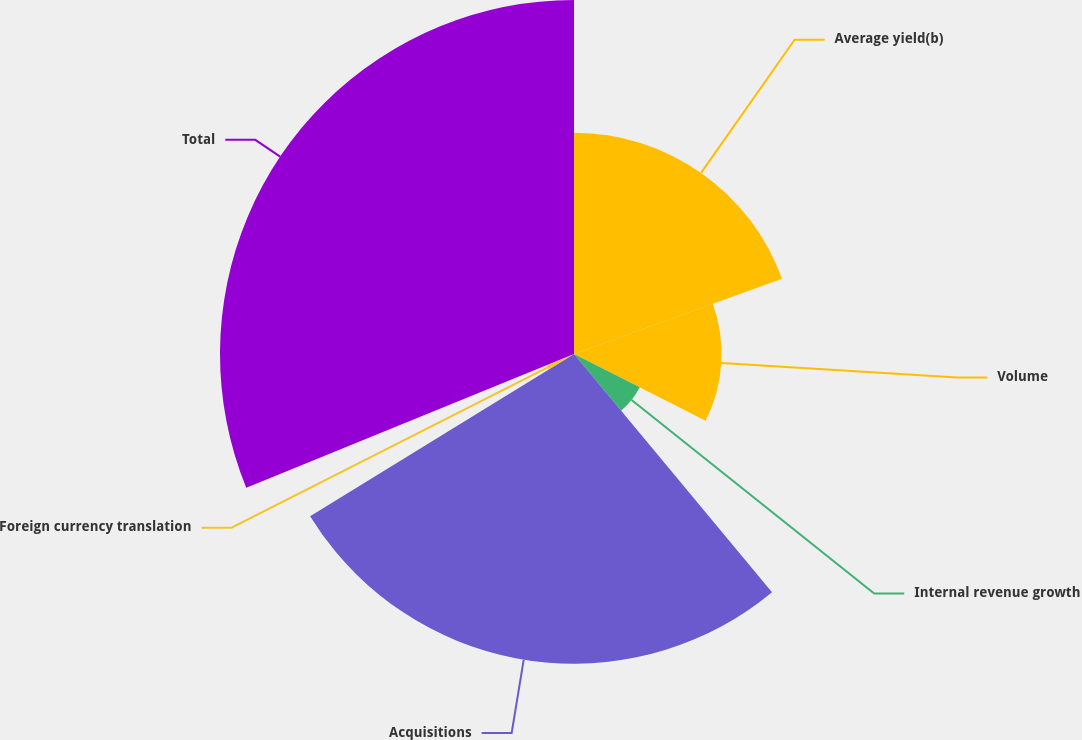Convert chart to OTSL. <chart><loc_0><loc_0><loc_500><loc_500><pie_chart><fcel>Average yield(b)<fcel>Volume<fcel>Internal revenue growth<fcel>Acquisitions<fcel>Foreign currency translation<fcel>Total<nl><fcel>19.48%<fcel>12.99%<fcel>6.49%<fcel>27.27%<fcel>2.6%<fcel>31.17%<nl></chart> 